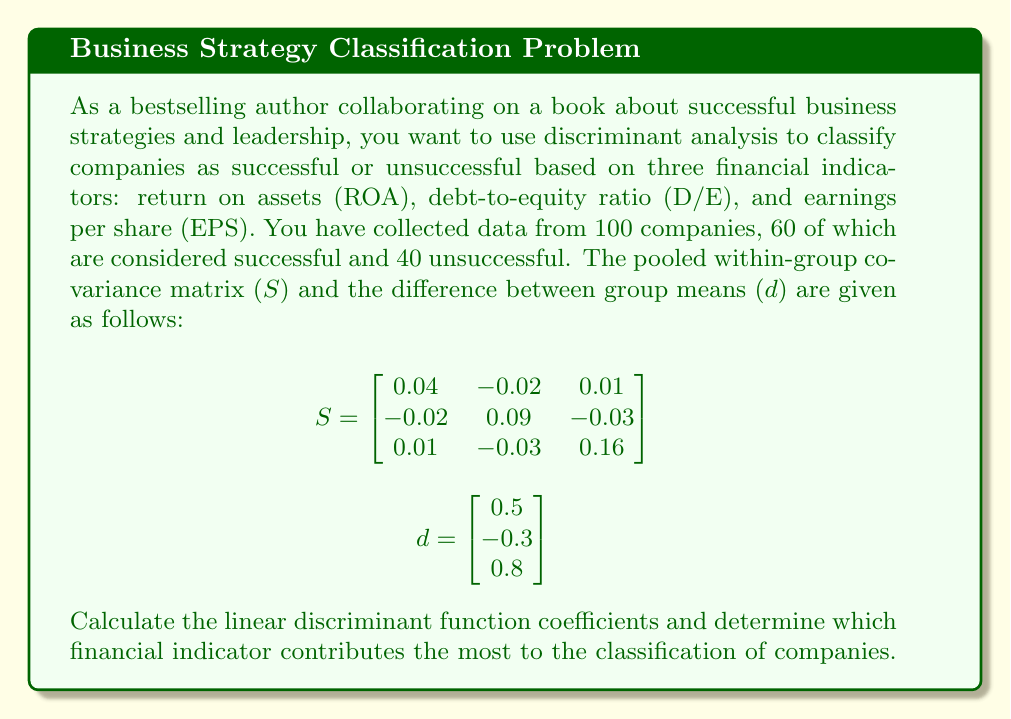Give your solution to this math problem. To solve this problem, we need to follow these steps:

1. Calculate the linear discriminant function coefficients using the formula:
   $$a = S^{-1}d$$

2. Find the inverse of the pooled within-group covariance matrix (S):
   $$S^{-1} = \begin{bmatrix}
   27.31 & 6.48 & -1.85 \\
   6.48 & 13.43 & 2.78 \\
   -1.85 & 2.78 & 6.94
   \end{bmatrix}$$

3. Multiply $S^{-1}$ by $d$ to get the linear discriminant function coefficients:
   $$a = S^{-1}d = \begin{bmatrix}
   27.31 & 6.48 & -1.85 \\
   6.48 & 13.43 & 2.78 \\
   -1.85 & 2.78 & 6.94
   \end{bmatrix} \times \begin{bmatrix}
   0.5 \\
   -0.3 \\
   0.8
   \end{bmatrix}$$

   $$a = \begin{bmatrix}
   11.40 \\
   -0.91 \\
   5.20
   \end{bmatrix}$$

4. Interpret the results:
   - The coefficient for ROA is 11.40
   - The coefficient for D/E is -0.91
   - The coefficient for EPS is 5.20

5. Determine which financial indicator contributes the most to the classification:
   The absolute value of the coefficient indicates the relative importance of each variable in the discriminant function. The larger the absolute value, the more important the variable is in discriminating between successful and unsuccessful companies.

   In this case, ROA has the largest absolute value (11.40), followed by EPS (5.20), and then D/E (-0.91).
Answer: The linear discriminant function coefficients are:
$$a = \begin{bmatrix}
11.40 \\
-0.91 \\
5.20
\end{bmatrix}$$

Return on Assets (ROA) contributes the most to the classification of companies, followed by Earnings Per Share (EPS), and then Debt-to-Equity ratio (D/E). 